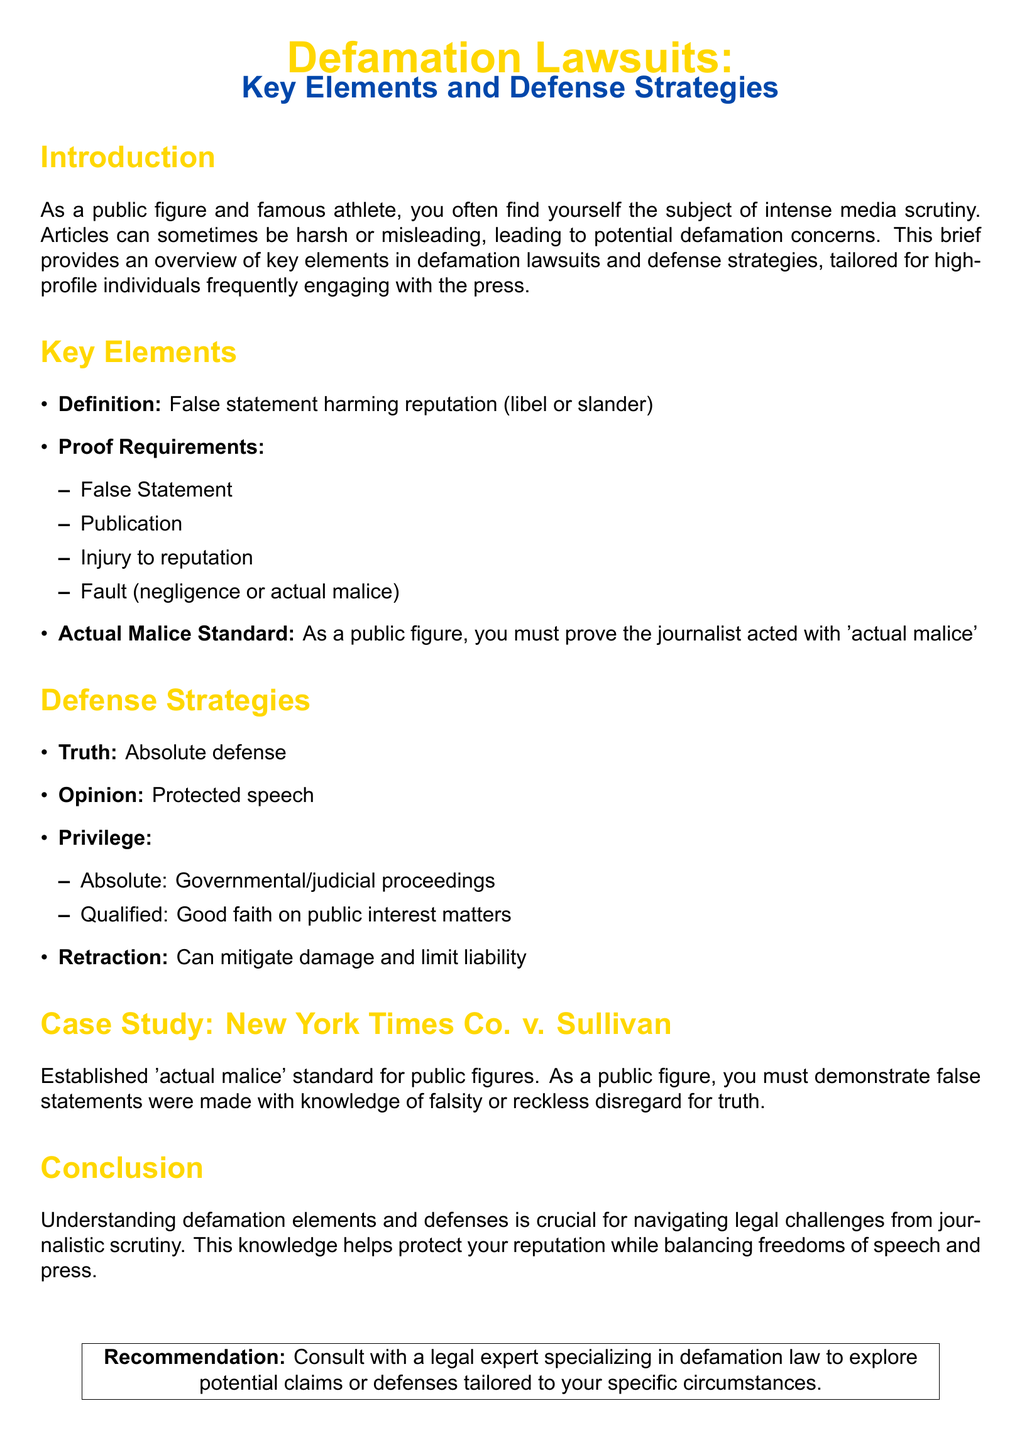What is the main topic of the document? The main topic is introduced in the title and revolves around defamation lawsuits, specifically aimed at high-profile individuals.
Answer: Defamation Lawsuits What are the key elements of defamation? The section outlines the major components required to establish a defamation claim, including various proofs.
Answer: Definition, Proof Requirements, Actual Malice Standard How many proof requirements are listed? Counting the items listed under proof requirements in the document reveals how many are necessary for a defamation claim.
Answer: Four What is the absolute defense against defamation? According to the defensive strategies outlined, the defense that can completely absolve liability is specified clearly.
Answer: Truth What standard must public figures prove in defamation cases? The document specifies a particular standard that public figures must demonstrate regarding the journalist's conduct.
Answer: Actual malice What does 'qualified privilege' refer to? The section discusses privileges available to journalists under certain conditions, specifically mentioning good faith.
Answer: Good faith on public interest matters Which case established the 'actual malice' standard? A specific case is provided in the document that serves as a legal precedent for public figures in defamation.
Answer: New York Times Co. v. Sullivan What is recommended for further support in defamation cases? The conclusion section provides advice for individuals seeking to navigate defamation claims and to whom they should consult.
Answer: Consult with a legal expert 